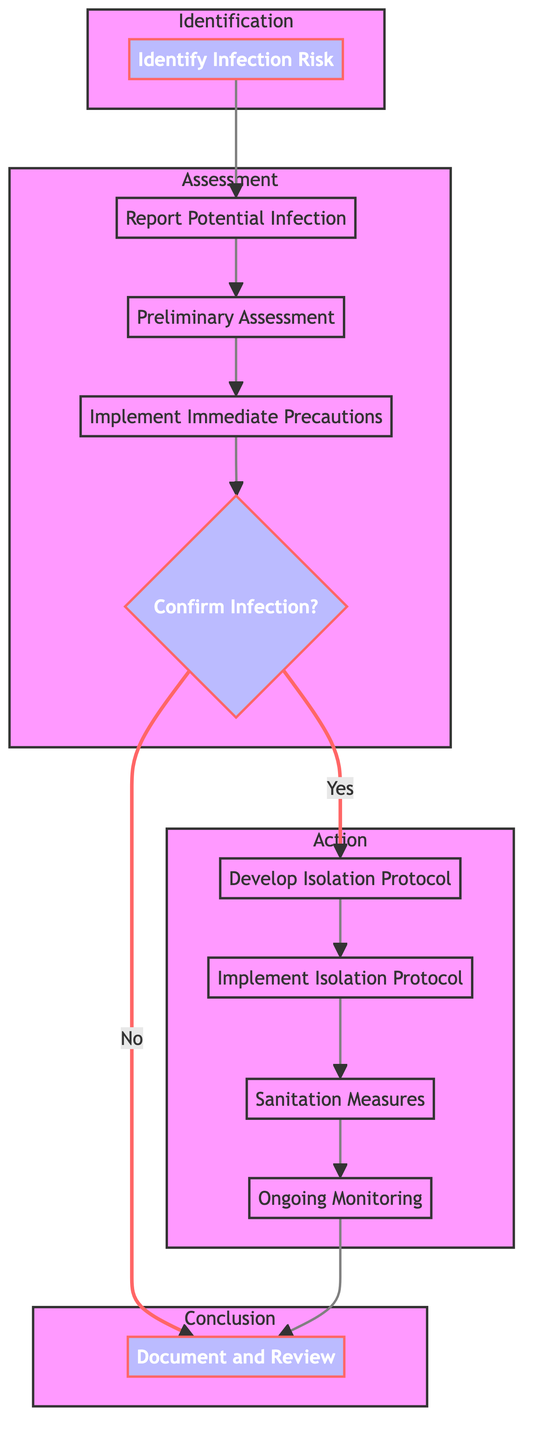What is the first step in the flowchart? The first step, located at the top of the diagram, is "Identify Infection Risk." This is the starting point of the infection control procedures.
Answer: Identify Infection Risk How many main nodes are in the diagram? By counting all the distinct process nodes, we find there are 10 main nodes that represent different steps in the infection control procedures.
Answer: 10 What step follows "Preliminary Assessment"? The step that follows "Preliminary Assessment" is "Implement Immediate Precautions," as indicated by the directional flow leading from one node to the next.
Answer: Implement Immediate Precautions What decision point is present in the flowchart? The flowchart includes a decision point labeled "Confirm Infection?" It branches the flow based on whether the infection is confirmed or not.
Answer: Confirm Infection? If infection is confirmed, what is the next step? When infection is confirmed, the next step is to "Develop Isolation Protocol," which follows directly from the decision point indicating confirmation.
Answer: Develop Isolation Protocol What is the last step in the overall process? The last step in the flow of the chart, after "Ongoing Monitoring," leads to the concluding step "Document and Review," marking the end of the procedures described.
Answer: Document and Review How are sanitation measures implemented in the process? "Sanitation Measures" follow the "Implement Isolation Protocol" step, indicating that sanitation occurs after isolation procedures are established to control infection spread.
Answer: Sanitation Measures What describes the relationship between "Confirm Infection" and "Document and Review"? The relationship is that "Confirm Infection" provides two paths: if confirmed, the flow moves to isolation protocols; if not confirmed, it flows directly to "Document and Review."
Answer: Two paths Which step involves the use of Personal Protective Equipment? The use of Personal Protective Equipment is part of the "Implement Immediate Precautions," which occurs early in the infection control procedures.
Answer: Implement Immediate Precautions 